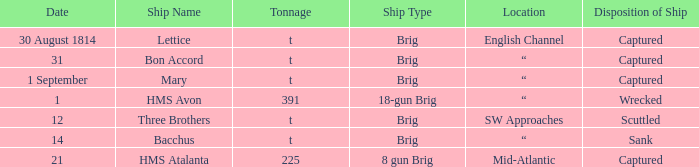With 14 under the date, what is the tonnage of the ship? T. Parse the full table. {'header': ['Date', 'Ship Name', 'Tonnage', 'Ship Type', 'Location', 'Disposition of Ship'], 'rows': [['30 August 1814', 'Lettice', 't', 'Brig', 'English Channel', 'Captured'], ['31', 'Bon Accord', 't', 'Brig', '“', 'Captured'], ['1 September', 'Mary', 't', 'Brig', '“', 'Captured'], ['1', 'HMS Avon', '391', '18-gun Brig', '“', 'Wrecked'], ['12', 'Three Brothers', 't', 'Brig', 'SW Approaches', 'Scuttled'], ['14', 'Bacchus', 't', 'Brig', '“', 'Sank'], ['21', 'HMS Atalanta', '225', '8 gun Brig', 'Mid-Atlantic', 'Captured']]} 